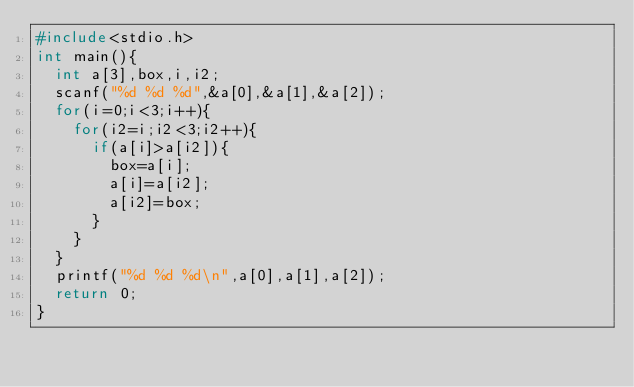Convert code to text. <code><loc_0><loc_0><loc_500><loc_500><_C++_>#include<stdio.h>
int main(){
	int a[3],box,i,i2;
	scanf("%d %d %d",&a[0],&a[1],&a[2]);
	for(i=0;i<3;i++){
		for(i2=i;i2<3;i2++){
			if(a[i]>a[i2]){
				box=a[i];
				a[i]=a[i2];
				a[i2]=box;
			}
		}
	}
	printf("%d %d %d\n",a[0],a[1],a[2]);
	return 0;
}</code> 